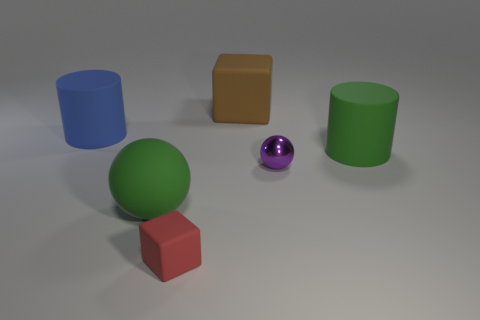Add 2 blue shiny cubes. How many objects exist? 8 Subtract 1 cylinders. How many cylinders are left? 1 Subtract 0 cyan spheres. How many objects are left? 6 Subtract all cubes. How many objects are left? 4 Subtract all red cylinders. Subtract all red balls. How many cylinders are left? 2 Subtract all brown rubber things. Subtract all cyan blocks. How many objects are left? 5 Add 2 rubber objects. How many rubber objects are left? 7 Add 5 large brown cubes. How many large brown cubes exist? 6 